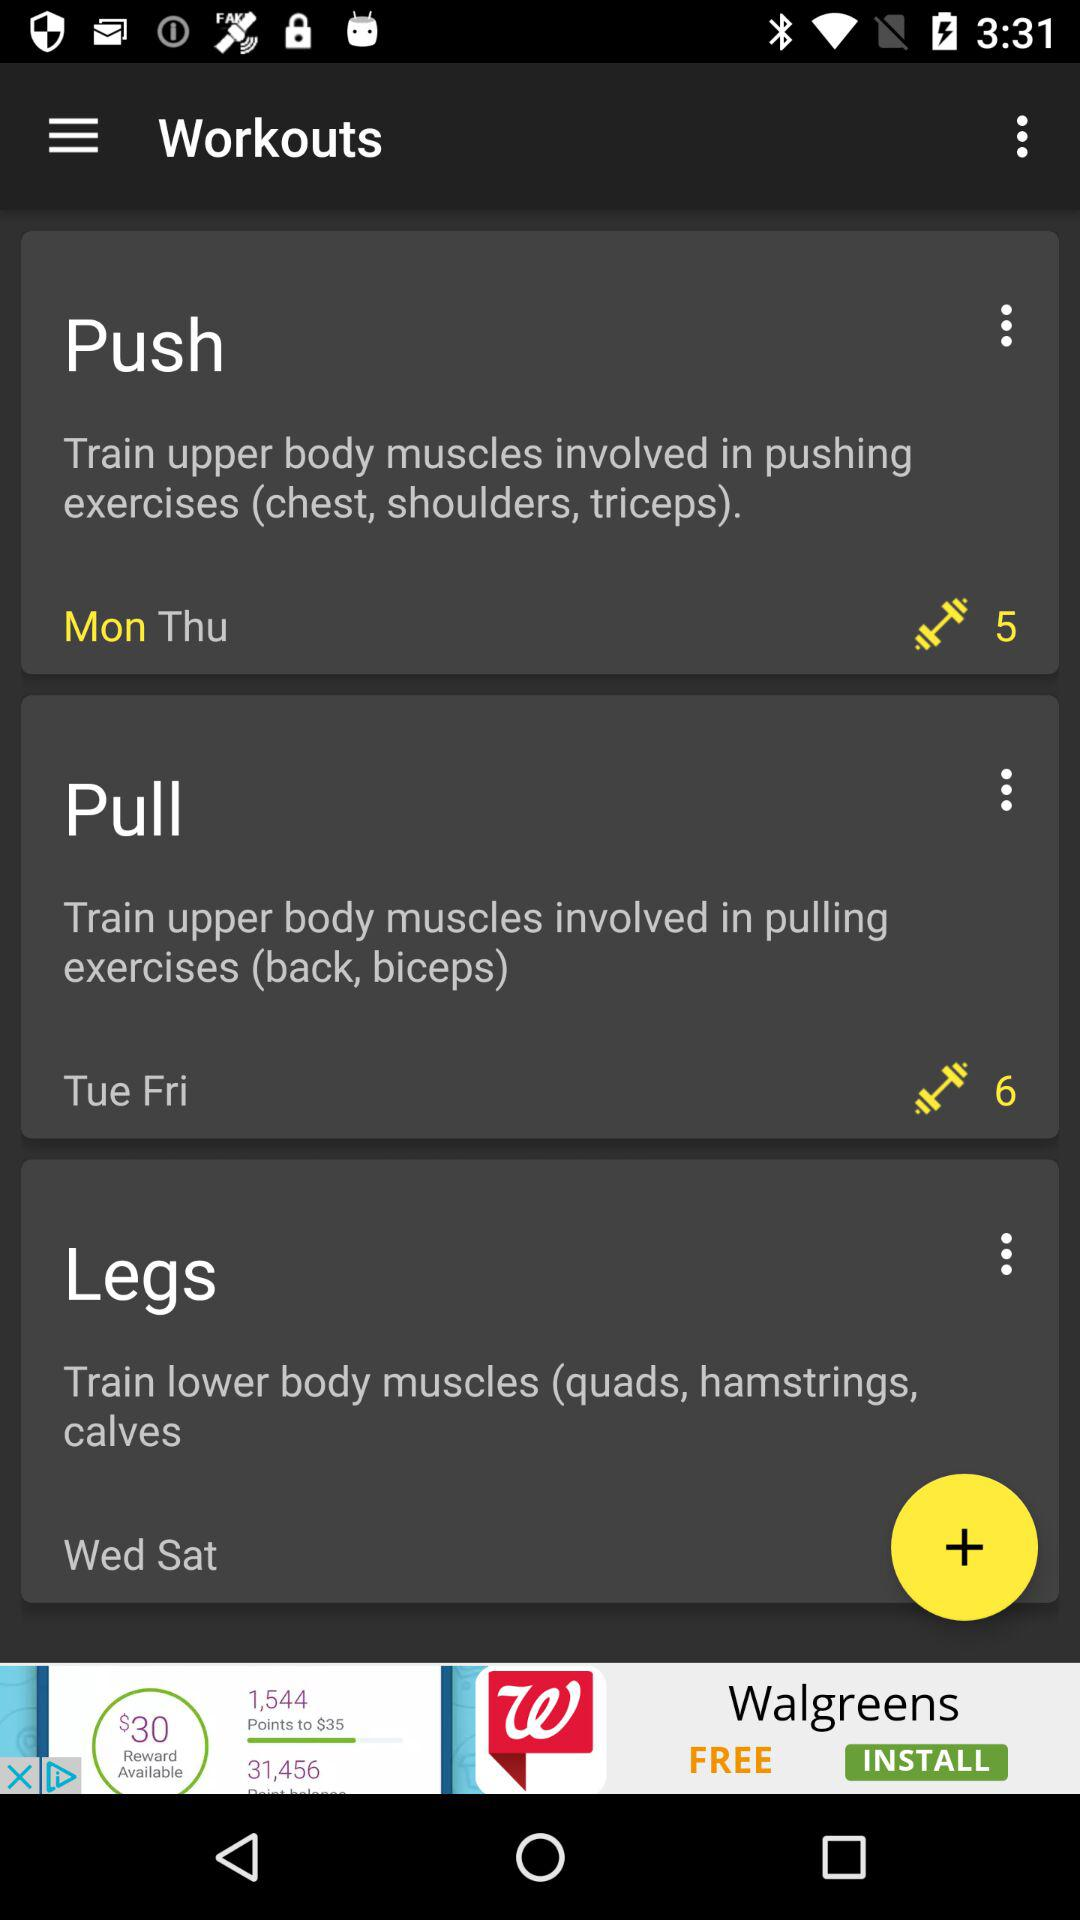How many workouts are there?
Answer the question using a single word or phrase. 3 